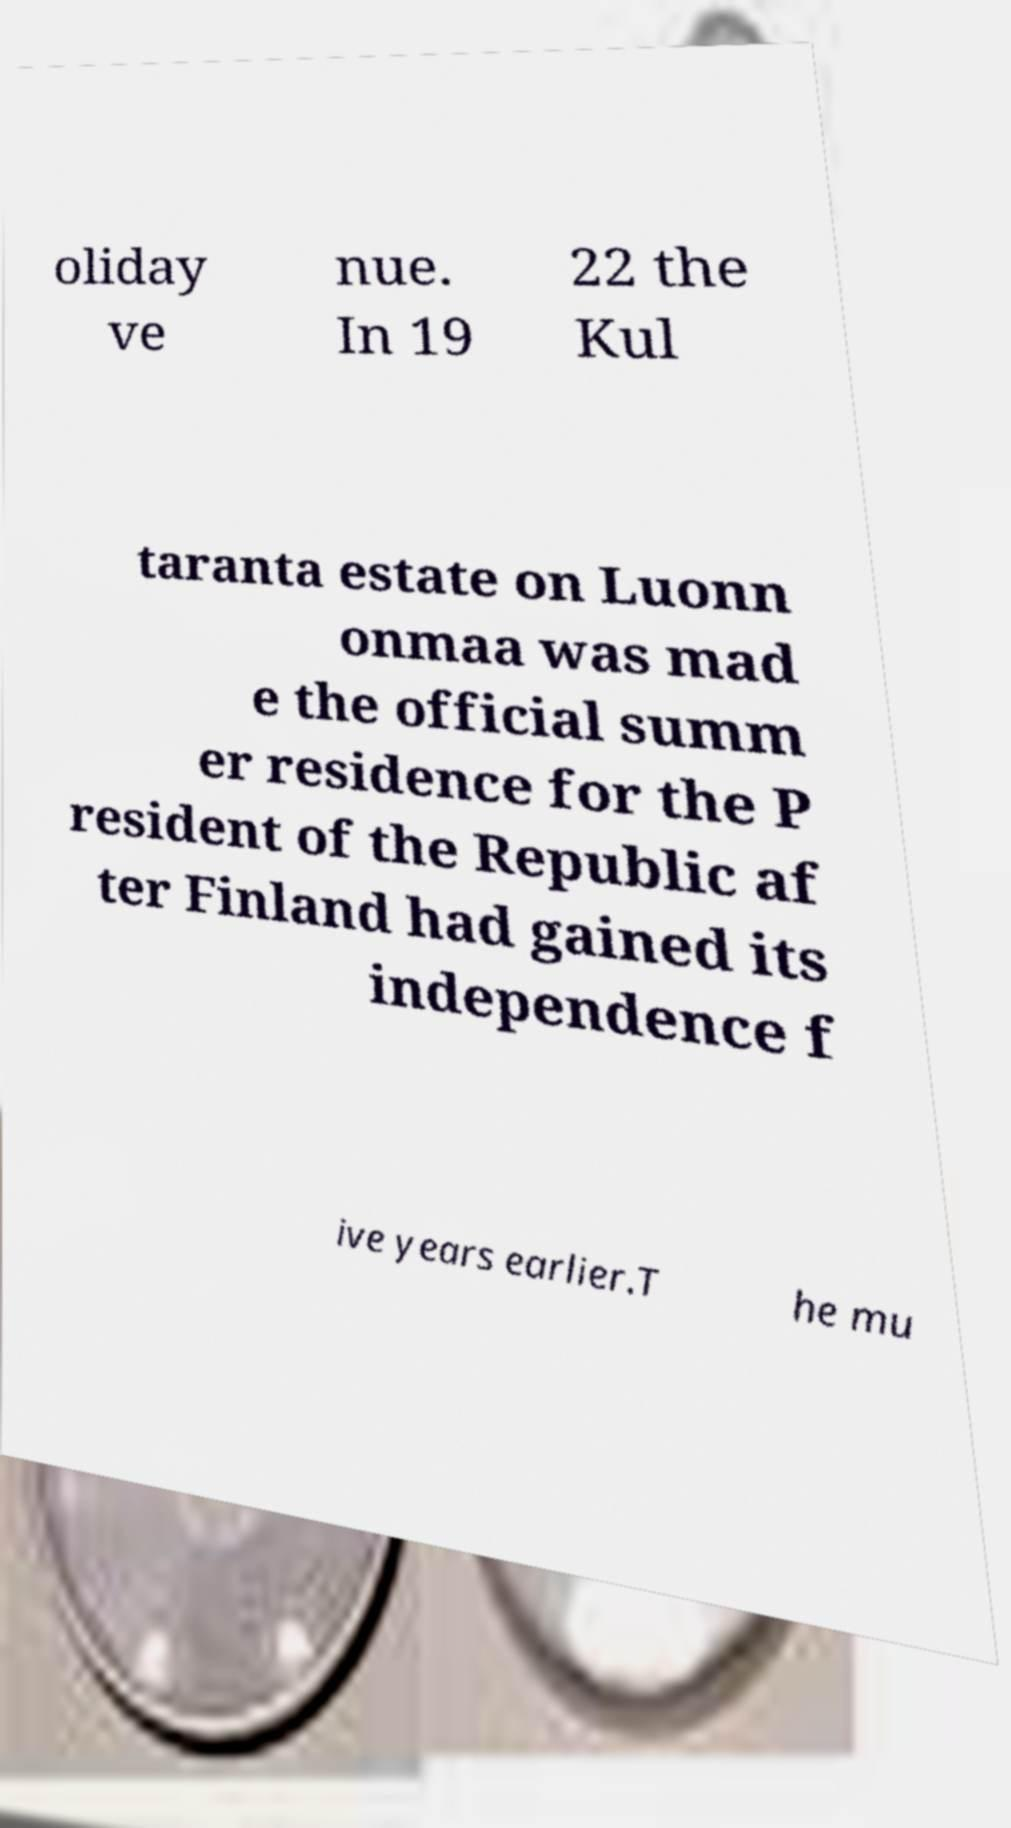Can you accurately transcribe the text from the provided image for me? oliday ve nue. In 19 22 the Kul taranta estate on Luonn onmaa was mad e the official summ er residence for the P resident of the Republic af ter Finland had gained its independence f ive years earlier.T he mu 